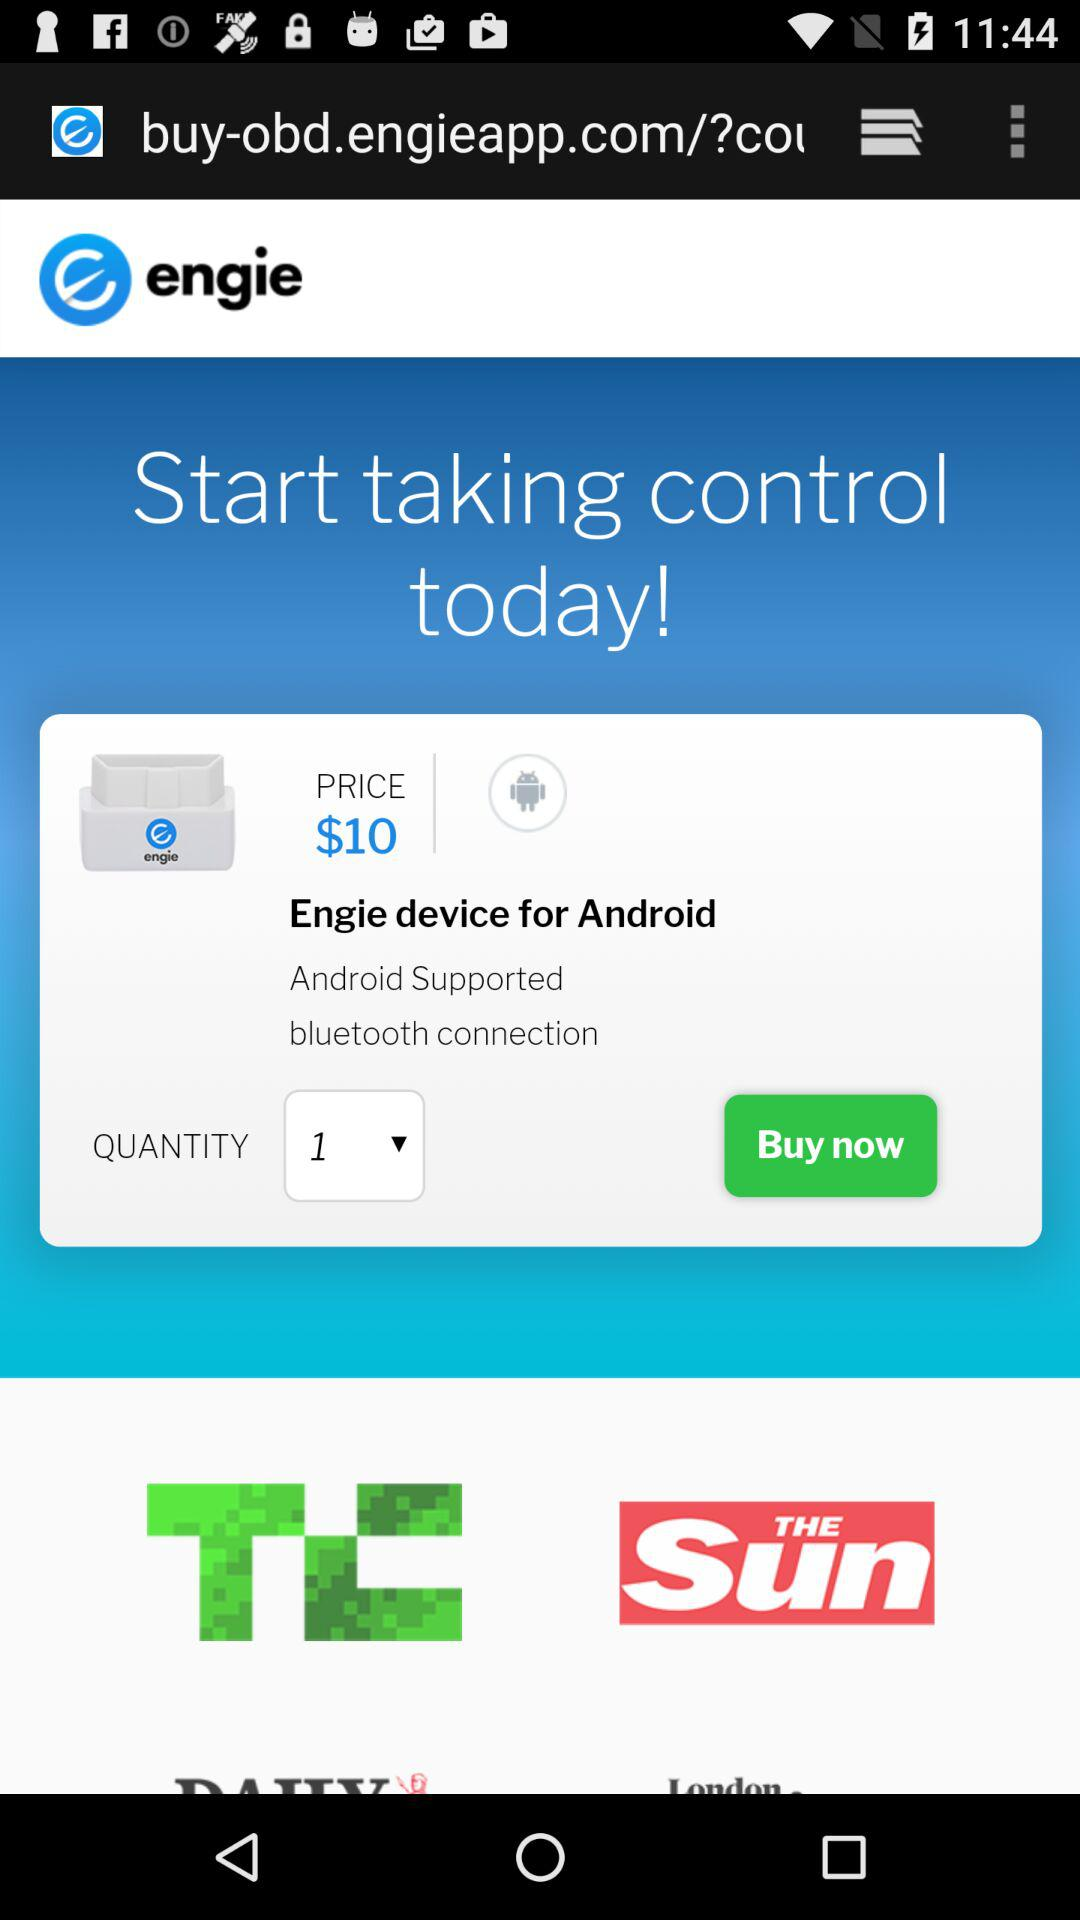What's the quantity? The quantity is 1. 